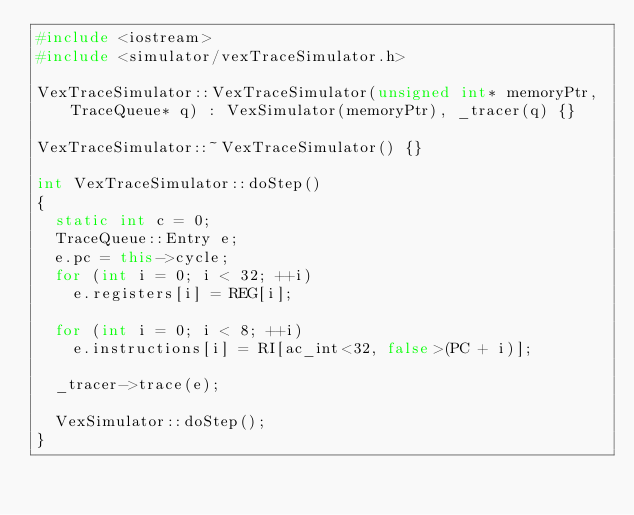<code> <loc_0><loc_0><loc_500><loc_500><_C++_>#include <iostream>
#include <simulator/vexTraceSimulator.h>

VexTraceSimulator::VexTraceSimulator(unsigned int* memoryPtr, TraceQueue* q) : VexSimulator(memoryPtr), _tracer(q) {}

VexTraceSimulator::~VexTraceSimulator() {}

int VexTraceSimulator::doStep()
{
  static int c = 0;
  TraceQueue::Entry e;
  e.pc = this->cycle;
  for (int i = 0; i < 32; ++i)
    e.registers[i] = REG[i];

  for (int i = 0; i < 8; ++i)
    e.instructions[i] = RI[ac_int<32, false>(PC + i)];

  _tracer->trace(e);

  VexSimulator::doStep();
}
</code> 